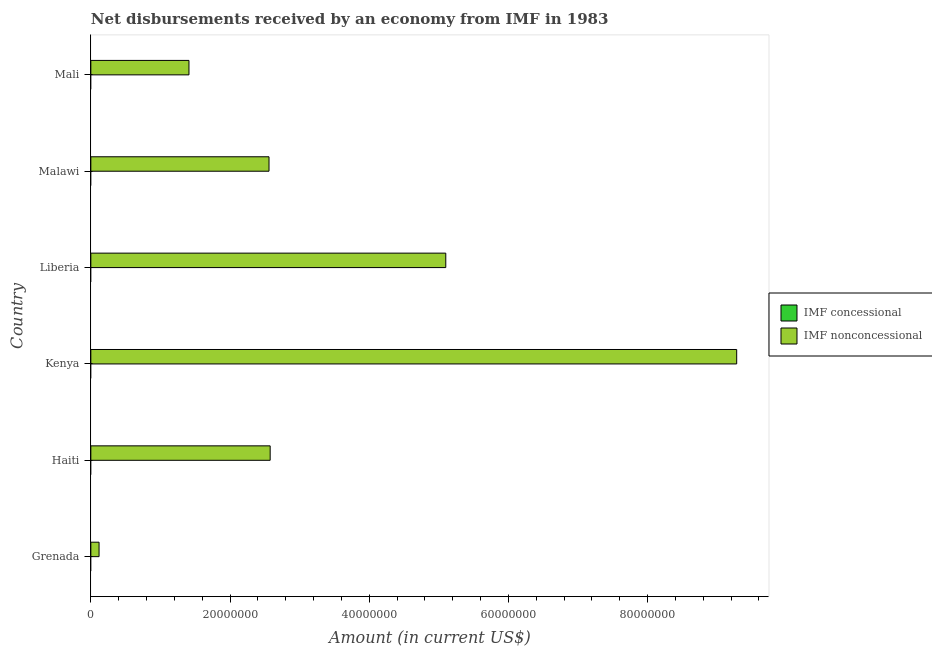How many different coloured bars are there?
Your answer should be compact. 1. Are the number of bars on each tick of the Y-axis equal?
Your answer should be very brief. Yes. How many bars are there on the 4th tick from the top?
Offer a terse response. 1. What is the label of the 2nd group of bars from the top?
Offer a very short reply. Malawi. What is the net concessional disbursements from imf in Kenya?
Ensure brevity in your answer.  0. Across all countries, what is the maximum net non concessional disbursements from imf?
Give a very brief answer. 9.28e+07. In which country was the net non concessional disbursements from imf maximum?
Your answer should be compact. Kenya. What is the difference between the net non concessional disbursements from imf in Malawi and that in Mali?
Offer a terse response. 1.15e+07. What is the difference between the net concessional disbursements from imf in Mali and the net non concessional disbursements from imf in Malawi?
Your answer should be compact. -2.56e+07. What is the average net non concessional disbursements from imf per country?
Your answer should be very brief. 3.51e+07. In how many countries, is the net non concessional disbursements from imf greater than 68000000 US$?
Provide a succinct answer. 1. What is the ratio of the net non concessional disbursements from imf in Malawi to that in Mali?
Your answer should be very brief. 1.82. Is the net non concessional disbursements from imf in Liberia less than that in Mali?
Your response must be concise. No. What is the difference between the highest and the second highest net non concessional disbursements from imf?
Make the answer very short. 4.18e+07. What is the difference between the highest and the lowest net non concessional disbursements from imf?
Provide a succinct answer. 9.16e+07. In how many countries, is the net concessional disbursements from imf greater than the average net concessional disbursements from imf taken over all countries?
Your answer should be very brief. 0. Is the sum of the net non concessional disbursements from imf in Liberia and Mali greater than the maximum net concessional disbursements from imf across all countries?
Your answer should be compact. Yes. Are all the bars in the graph horizontal?
Make the answer very short. Yes. What is the difference between two consecutive major ticks on the X-axis?
Provide a succinct answer. 2.00e+07. Where does the legend appear in the graph?
Keep it short and to the point. Center right. How many legend labels are there?
Offer a very short reply. 2. How are the legend labels stacked?
Offer a terse response. Vertical. What is the title of the graph?
Your answer should be compact. Net disbursements received by an economy from IMF in 1983. What is the label or title of the X-axis?
Keep it short and to the point. Amount (in current US$). What is the label or title of the Y-axis?
Give a very brief answer. Country. What is the Amount (in current US$) in IMF nonconcessional in Grenada?
Offer a very short reply. 1.18e+06. What is the Amount (in current US$) of IMF nonconcessional in Haiti?
Provide a short and direct response. 2.58e+07. What is the Amount (in current US$) of IMF nonconcessional in Kenya?
Offer a very short reply. 9.28e+07. What is the Amount (in current US$) of IMF concessional in Liberia?
Offer a terse response. 0. What is the Amount (in current US$) of IMF nonconcessional in Liberia?
Ensure brevity in your answer.  5.10e+07. What is the Amount (in current US$) in IMF concessional in Malawi?
Your answer should be compact. 0. What is the Amount (in current US$) of IMF nonconcessional in Malawi?
Provide a succinct answer. 2.56e+07. What is the Amount (in current US$) of IMF nonconcessional in Mali?
Offer a very short reply. 1.41e+07. Across all countries, what is the maximum Amount (in current US$) of IMF nonconcessional?
Provide a succinct answer. 9.28e+07. Across all countries, what is the minimum Amount (in current US$) of IMF nonconcessional?
Provide a short and direct response. 1.18e+06. What is the total Amount (in current US$) in IMF nonconcessional in the graph?
Your answer should be compact. 2.10e+08. What is the difference between the Amount (in current US$) in IMF nonconcessional in Grenada and that in Haiti?
Make the answer very short. -2.46e+07. What is the difference between the Amount (in current US$) of IMF nonconcessional in Grenada and that in Kenya?
Make the answer very short. -9.16e+07. What is the difference between the Amount (in current US$) of IMF nonconcessional in Grenada and that in Liberia?
Your answer should be compact. -4.98e+07. What is the difference between the Amount (in current US$) in IMF nonconcessional in Grenada and that in Malawi?
Provide a short and direct response. -2.44e+07. What is the difference between the Amount (in current US$) in IMF nonconcessional in Grenada and that in Mali?
Provide a short and direct response. -1.29e+07. What is the difference between the Amount (in current US$) in IMF nonconcessional in Haiti and that in Kenya?
Provide a short and direct response. -6.70e+07. What is the difference between the Amount (in current US$) of IMF nonconcessional in Haiti and that in Liberia?
Your answer should be compact. -2.52e+07. What is the difference between the Amount (in current US$) of IMF nonconcessional in Haiti and that in Malawi?
Your answer should be very brief. 1.66e+05. What is the difference between the Amount (in current US$) of IMF nonconcessional in Haiti and that in Mali?
Ensure brevity in your answer.  1.17e+07. What is the difference between the Amount (in current US$) in IMF nonconcessional in Kenya and that in Liberia?
Ensure brevity in your answer.  4.18e+07. What is the difference between the Amount (in current US$) of IMF nonconcessional in Kenya and that in Malawi?
Your response must be concise. 6.72e+07. What is the difference between the Amount (in current US$) in IMF nonconcessional in Kenya and that in Mali?
Make the answer very short. 7.87e+07. What is the difference between the Amount (in current US$) of IMF nonconcessional in Liberia and that in Malawi?
Offer a very short reply. 2.54e+07. What is the difference between the Amount (in current US$) of IMF nonconcessional in Liberia and that in Mali?
Offer a terse response. 3.69e+07. What is the difference between the Amount (in current US$) in IMF nonconcessional in Malawi and that in Mali?
Give a very brief answer. 1.15e+07. What is the average Amount (in current US$) of IMF nonconcessional per country?
Offer a terse response. 3.51e+07. What is the ratio of the Amount (in current US$) in IMF nonconcessional in Grenada to that in Haiti?
Your answer should be very brief. 0.05. What is the ratio of the Amount (in current US$) of IMF nonconcessional in Grenada to that in Kenya?
Provide a short and direct response. 0.01. What is the ratio of the Amount (in current US$) of IMF nonconcessional in Grenada to that in Liberia?
Ensure brevity in your answer.  0.02. What is the ratio of the Amount (in current US$) of IMF nonconcessional in Grenada to that in Malawi?
Provide a short and direct response. 0.05. What is the ratio of the Amount (in current US$) of IMF nonconcessional in Grenada to that in Mali?
Your response must be concise. 0.08. What is the ratio of the Amount (in current US$) of IMF nonconcessional in Haiti to that in Kenya?
Your answer should be very brief. 0.28. What is the ratio of the Amount (in current US$) in IMF nonconcessional in Haiti to that in Liberia?
Your answer should be compact. 0.51. What is the ratio of the Amount (in current US$) of IMF nonconcessional in Haiti to that in Malawi?
Your answer should be very brief. 1.01. What is the ratio of the Amount (in current US$) of IMF nonconcessional in Haiti to that in Mali?
Provide a short and direct response. 1.83. What is the ratio of the Amount (in current US$) of IMF nonconcessional in Kenya to that in Liberia?
Make the answer very short. 1.82. What is the ratio of the Amount (in current US$) of IMF nonconcessional in Kenya to that in Malawi?
Your answer should be very brief. 3.62. What is the ratio of the Amount (in current US$) in IMF nonconcessional in Kenya to that in Mali?
Make the answer very short. 6.58. What is the ratio of the Amount (in current US$) of IMF nonconcessional in Liberia to that in Malawi?
Keep it short and to the point. 1.99. What is the ratio of the Amount (in current US$) of IMF nonconcessional in Liberia to that in Mali?
Offer a very short reply. 3.62. What is the ratio of the Amount (in current US$) in IMF nonconcessional in Malawi to that in Mali?
Your answer should be compact. 1.82. What is the difference between the highest and the second highest Amount (in current US$) of IMF nonconcessional?
Provide a succinct answer. 4.18e+07. What is the difference between the highest and the lowest Amount (in current US$) in IMF nonconcessional?
Ensure brevity in your answer.  9.16e+07. 